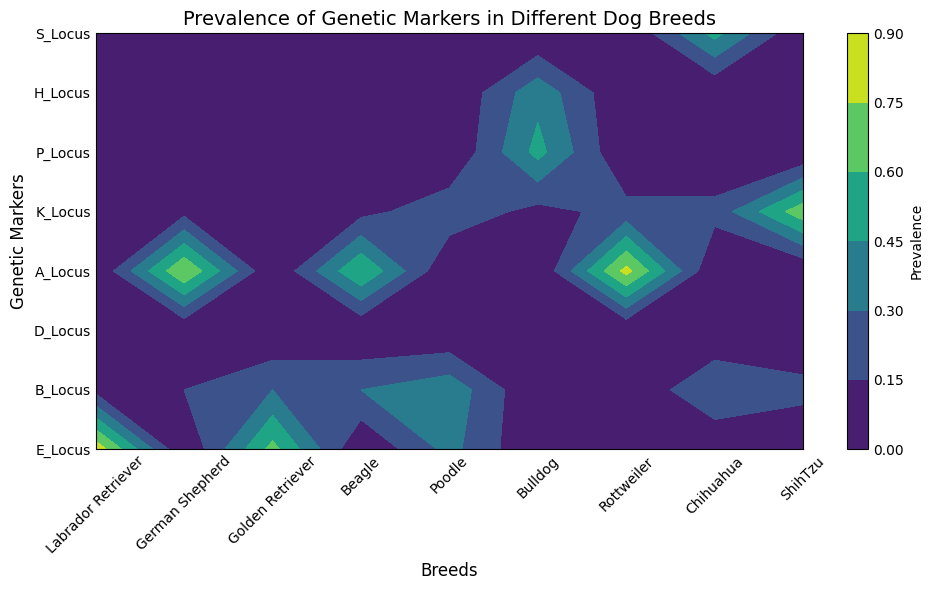Which breed has the highest prevalence of the E_Locus genetic marker? Look for the E_Locus row on the y-axis and check the values for all breeds on the x-axis. The Labrador Retriever has the highest prevalence value (0.85).
Answer: Labrador Retriever Which genetic marker has the lowest prevalence in Beagles? Locate the column for Beagle and compare the numbers in each row. The K_Locus genetic marker has the lowest prevalence (0.1).
Answer: K_Locus Between German Shepherd and Rottweiler, which breed has a higher prevalence of the A_Locus genetic marker? Identify the row for A_Locus and compare the values for German Shepherd (0.75) and Rottweiler (0.8). Rottweiler has a higher prevalence.
Answer: Rottweiler What is the combined prevalence of the B_Locus genetic marker for Golden Retriever and Poodle? Locate the B_Locus row. The Golden Retriever has a prevalence value of 0.3, and the Poodle has a value of 0.4. Summing them together, 0.3 + 0.4 = 0.7.
Answer: 0.7 Which genetic marker is associated with the highest prevalence in Bulldogs? Locate the column for Bulldog and compare all the prevalence values. The P_Locus genetic marker has the highest prevalence (0.5) in Bulldogs.
Answer: P_Locus What is the color pattern associated with the highest prevalence genetic marker in ShihTzus? Identify the highest prevalence in the ShihTzu column which is for the K_Locus genetic marker (0.7). The color pattern is Gold and White.
Answer: Gold and White Compare the prevalence of the K_Locus genetic marker in Labrador Retriever and ShihTzu. Which one is higher? Find the K_Locus row and check the values for Labrador Retriever (0.2) and ShihTzu (0.7). ShihTzu has a higher prevalence.
Answer: ShihTzu What is the average prevalence of the K_Locus genetic marker across all breeds? Sum the prevalences for K_Locus across all breeds: (0.05 (Labrador) + 0.1 (German Shepherd) + 0.05 (Golden Retriever) + 0.1 (Beagle) + 0.25 (Poodle) + 0.1 (Bulldog) + 0.2 (Rottweiler) + 0.2 (Chihuahua) + 0.7 (ShihTzu)) = 1.75. There are 9 breeds, so the average is 1.75 / 9 = 0.1944.
Answer: 0.1944 What is the second-most prevalent genetic marker in Golden Retrievers? Check the prevalence values for Golden Retriever: E_Locus (0.65), B_Locus (0.3), and K_Locus (0.05). The second highest is B_Locus (0.3).
Answer: B_Locus 